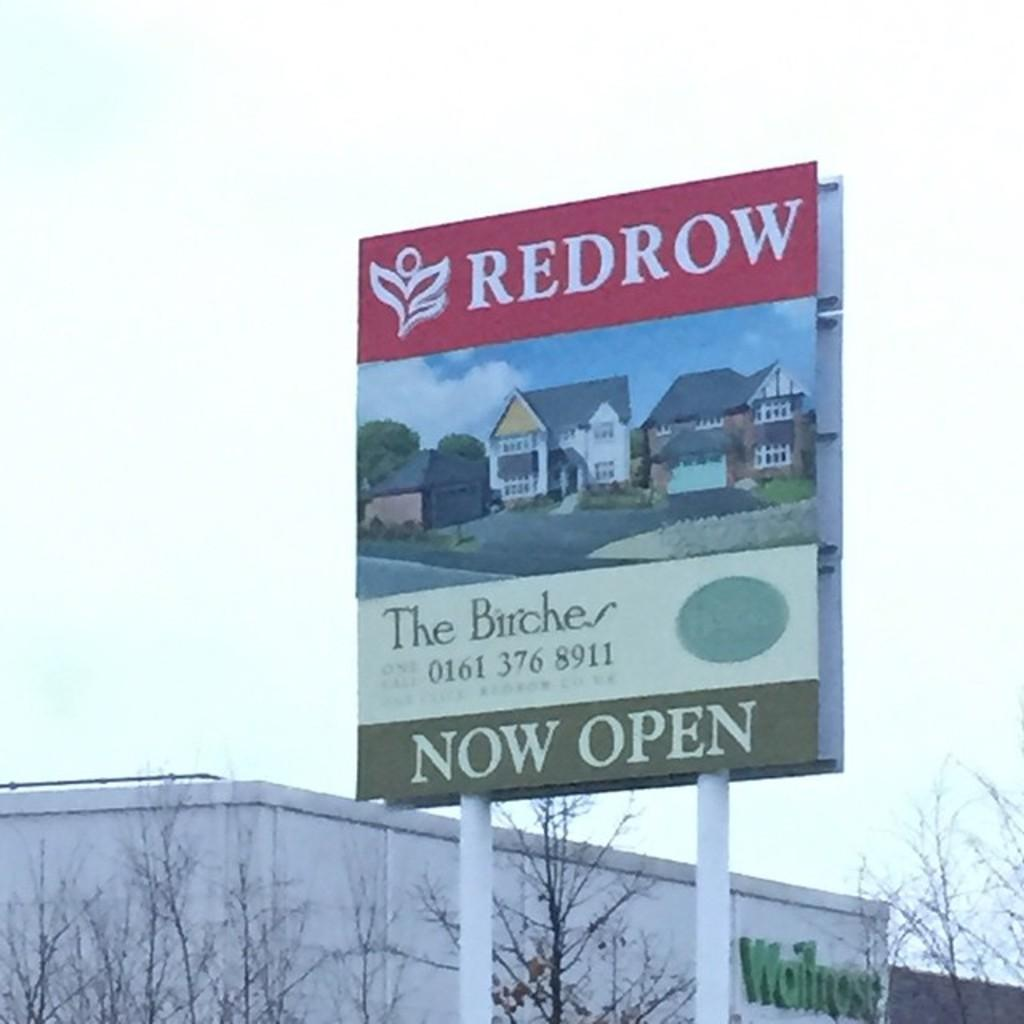Provide a one-sentence caption for the provided image. An artists rendering of homes on a sign advertising for The Birches residential development. 